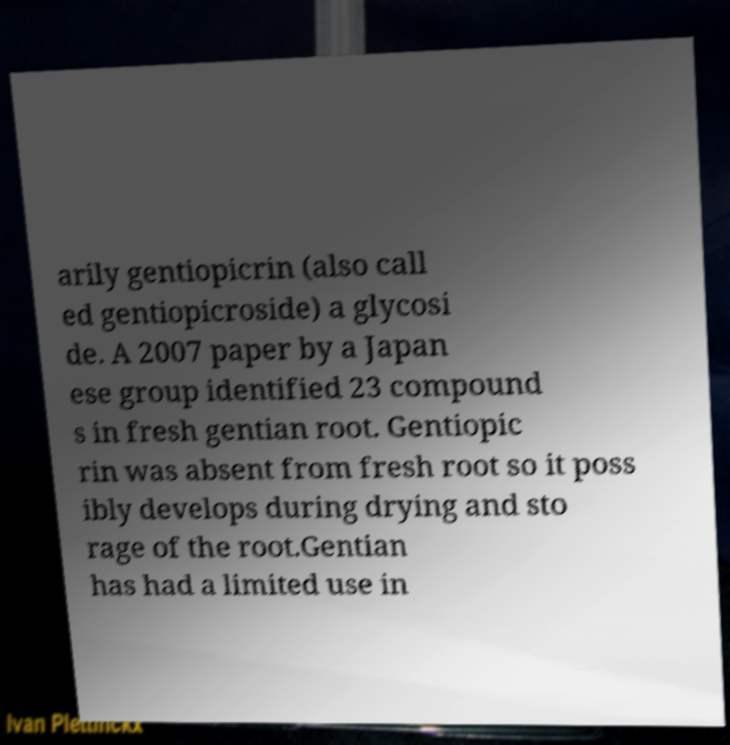Please identify and transcribe the text found in this image. arily gentiopicrin (also call ed gentiopicroside) a glycosi de. A 2007 paper by a Japan ese group identified 23 compound s in fresh gentian root. Gentiopic rin was absent from fresh root so it poss ibly develops during drying and sto rage of the root.Gentian has had a limited use in 